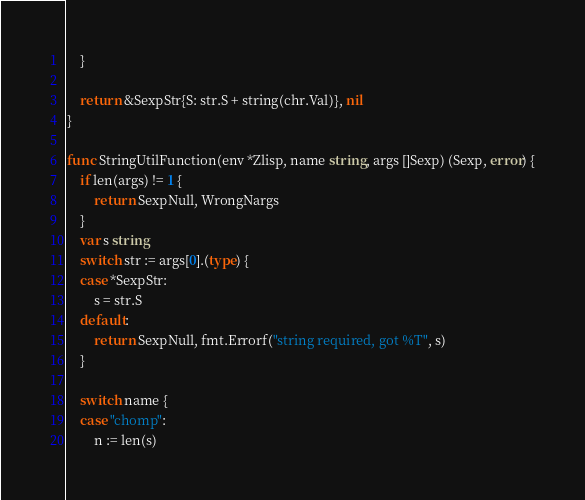<code> <loc_0><loc_0><loc_500><loc_500><_Go_>	}

	return &SexpStr{S: str.S + string(chr.Val)}, nil
}

func StringUtilFunction(env *Zlisp, name string, args []Sexp) (Sexp, error) {
	if len(args) != 1 {
		return SexpNull, WrongNargs
	}
	var s string
	switch str := args[0].(type) {
	case *SexpStr:
		s = str.S
	default:
		return SexpNull, fmt.Errorf("string required, got %T", s)
	}

	switch name {
	case "chomp":
		n := len(s)</code> 